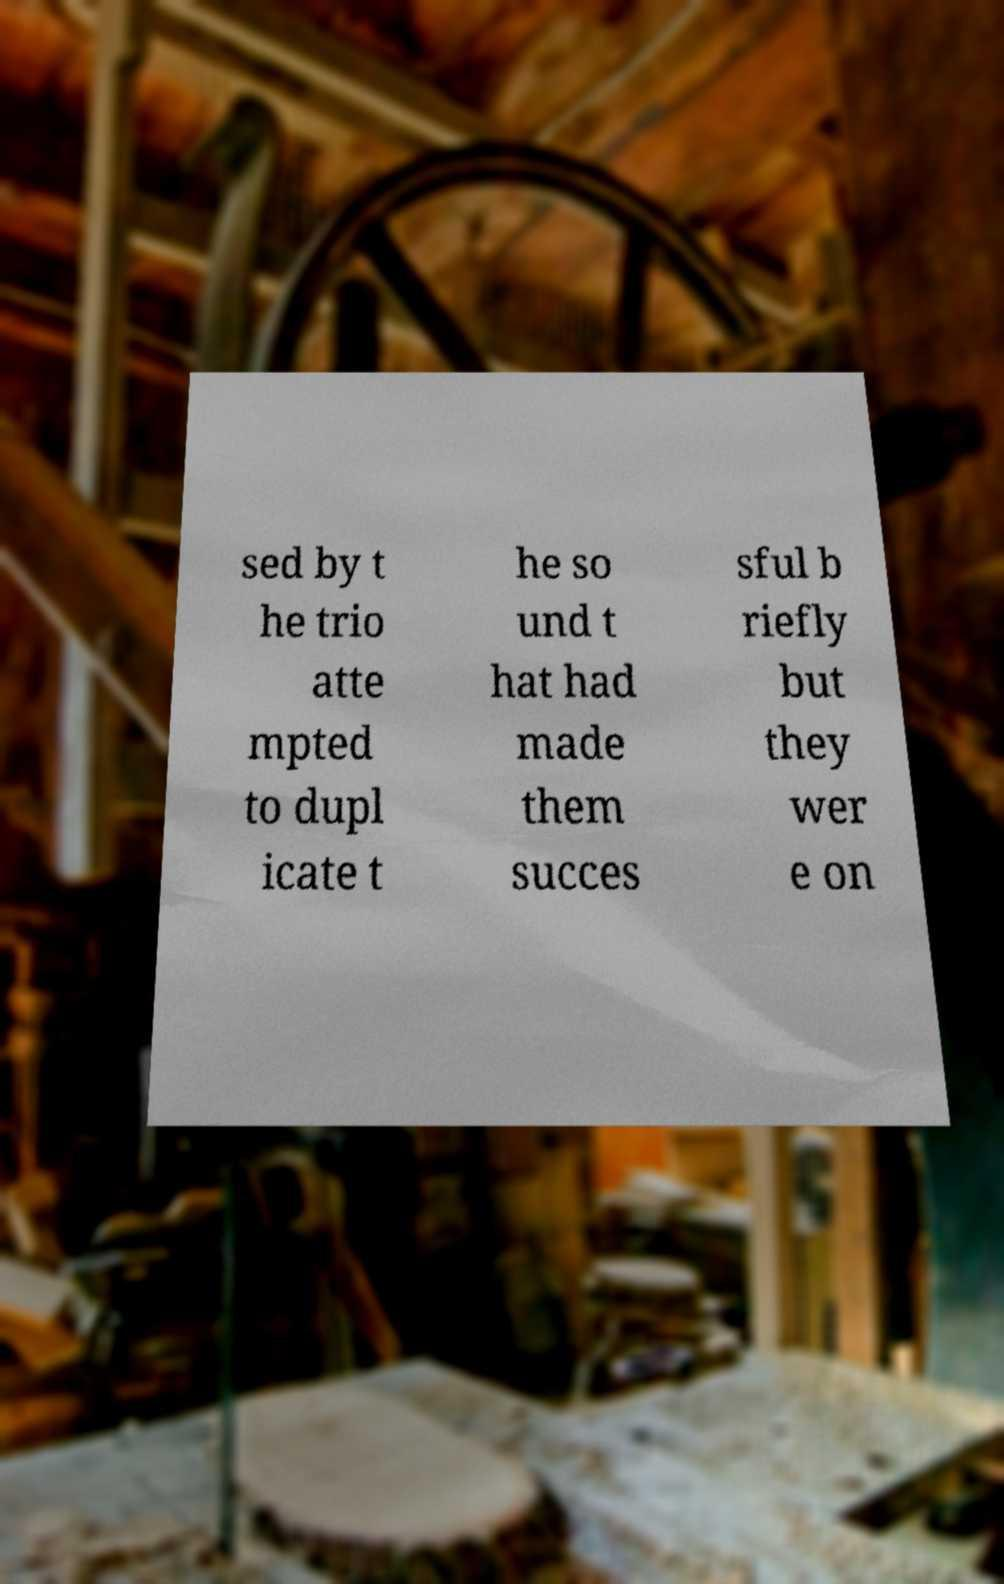There's text embedded in this image that I need extracted. Can you transcribe it verbatim? sed by t he trio atte mpted to dupl icate t he so und t hat had made them succes sful b riefly but they wer e on 